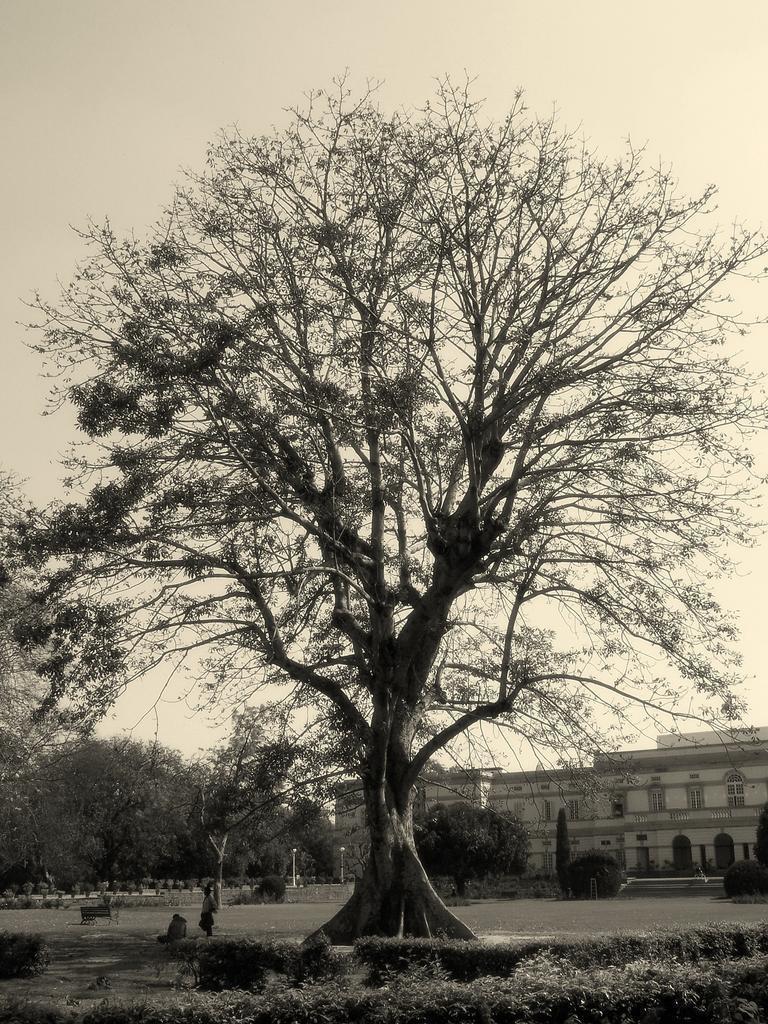Please provide a concise description of this image. This is a black and white image. In this image we can see a group of trees, grass, some plants, a person standing, some poles, a fence, some buildings and the sky which looks cloudy. 